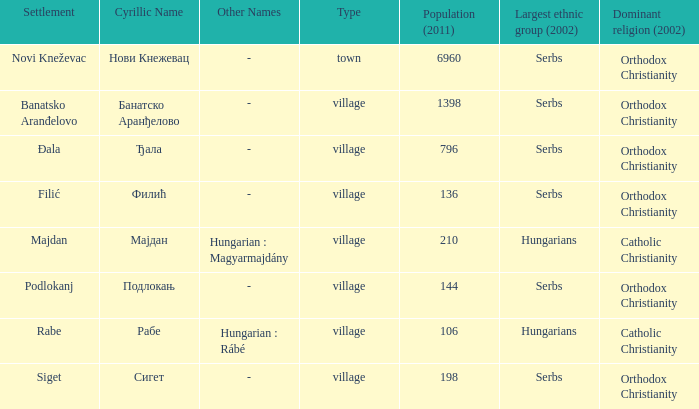What place is referred to by the cyrillic name сигет? Siget. 